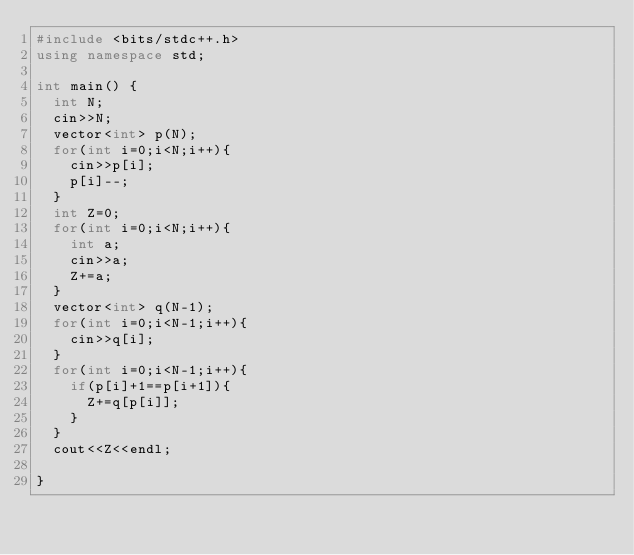<code> <loc_0><loc_0><loc_500><loc_500><_C++_>#include <bits/stdc++.h>
using namespace std;

int main() {
  int N;
  cin>>N;
  vector<int> p(N);
  for(int i=0;i<N;i++){
    cin>>p[i];
    p[i]--;
  }
  int Z=0;
  for(int i=0;i<N;i++){
    int a;
    cin>>a;
    Z+=a;
  }
  vector<int> q(N-1);
  for(int i=0;i<N-1;i++){
    cin>>q[i];
  }
  for(int i=0;i<N-1;i++){
    if(p[i]+1==p[i+1]){
      Z+=q[p[i]];
    }
  }
  cout<<Z<<endl;
    
}</code> 